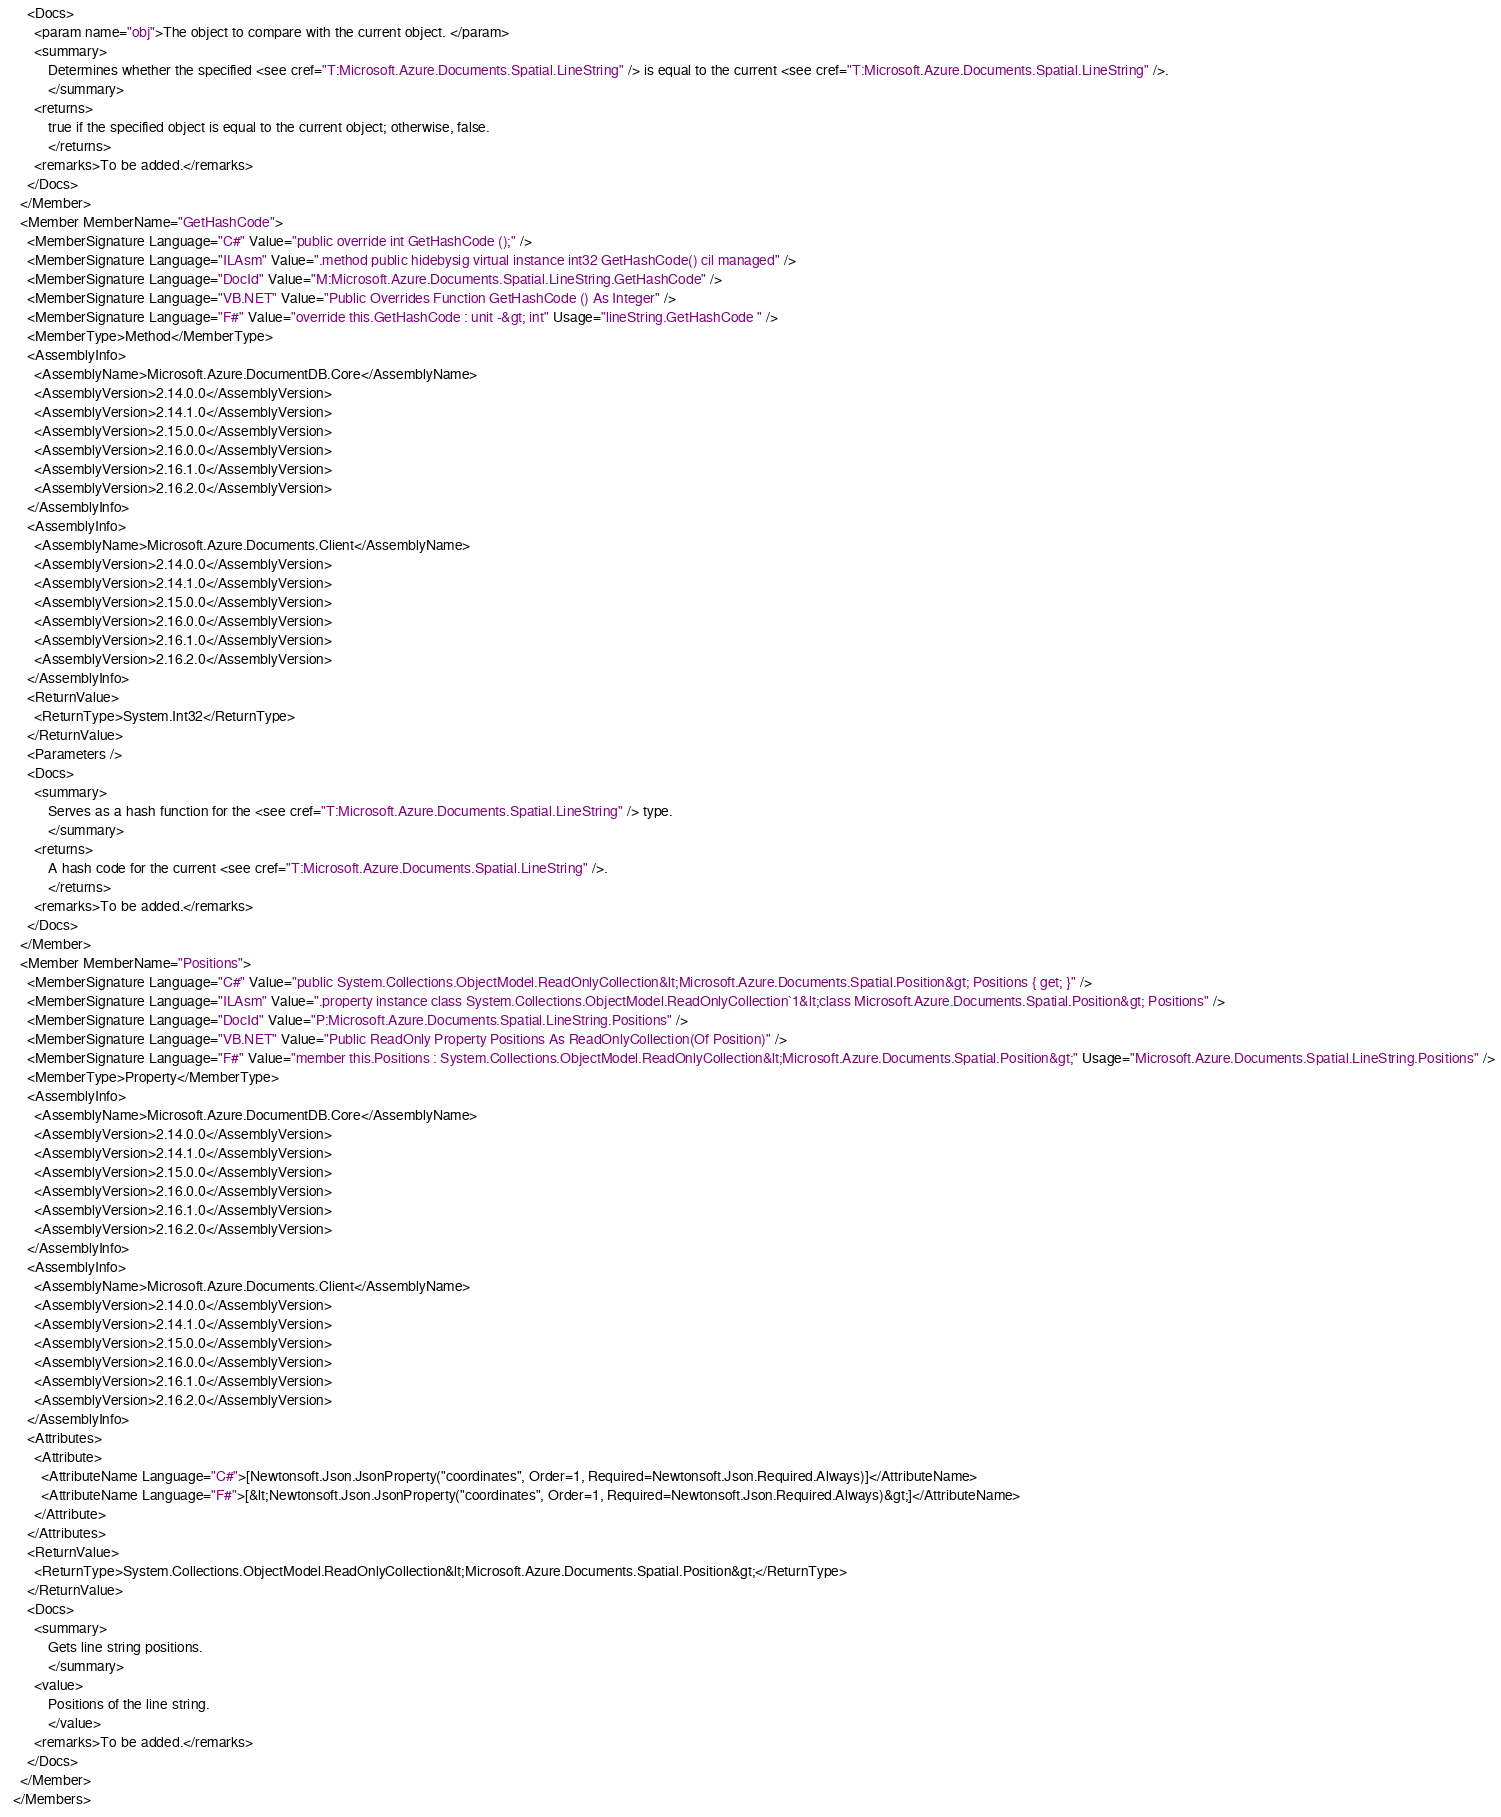Convert code to text. <code><loc_0><loc_0><loc_500><loc_500><_XML_>      <Docs>
        <param name="obj">The object to compare with the current object. </param>
        <summary>
            Determines whether the specified <see cref="T:Microsoft.Azure.Documents.Spatial.LineString" /> is equal to the current <see cref="T:Microsoft.Azure.Documents.Spatial.LineString" />.
            </summary>
        <returns>
            true if the specified object is equal to the current object; otherwise, false.
            </returns>
        <remarks>To be added.</remarks>
      </Docs>
    </Member>
    <Member MemberName="GetHashCode">
      <MemberSignature Language="C#" Value="public override int GetHashCode ();" />
      <MemberSignature Language="ILAsm" Value=".method public hidebysig virtual instance int32 GetHashCode() cil managed" />
      <MemberSignature Language="DocId" Value="M:Microsoft.Azure.Documents.Spatial.LineString.GetHashCode" />
      <MemberSignature Language="VB.NET" Value="Public Overrides Function GetHashCode () As Integer" />
      <MemberSignature Language="F#" Value="override this.GetHashCode : unit -&gt; int" Usage="lineString.GetHashCode " />
      <MemberType>Method</MemberType>
      <AssemblyInfo>
        <AssemblyName>Microsoft.Azure.DocumentDB.Core</AssemblyName>
        <AssemblyVersion>2.14.0.0</AssemblyVersion>
        <AssemblyVersion>2.14.1.0</AssemblyVersion>
        <AssemblyVersion>2.15.0.0</AssemblyVersion>
        <AssemblyVersion>2.16.0.0</AssemblyVersion>
        <AssemblyVersion>2.16.1.0</AssemblyVersion>
        <AssemblyVersion>2.16.2.0</AssemblyVersion>
      </AssemblyInfo>
      <AssemblyInfo>
        <AssemblyName>Microsoft.Azure.Documents.Client</AssemblyName>
        <AssemblyVersion>2.14.0.0</AssemblyVersion>
        <AssemblyVersion>2.14.1.0</AssemblyVersion>
        <AssemblyVersion>2.15.0.0</AssemblyVersion>
        <AssemblyVersion>2.16.0.0</AssemblyVersion>
        <AssemblyVersion>2.16.1.0</AssemblyVersion>
        <AssemblyVersion>2.16.2.0</AssemblyVersion>
      </AssemblyInfo>
      <ReturnValue>
        <ReturnType>System.Int32</ReturnType>
      </ReturnValue>
      <Parameters />
      <Docs>
        <summary>
            Serves as a hash function for the <see cref="T:Microsoft.Azure.Documents.Spatial.LineString" /> type.
            </summary>
        <returns>
            A hash code for the current <see cref="T:Microsoft.Azure.Documents.Spatial.LineString" />.
            </returns>
        <remarks>To be added.</remarks>
      </Docs>
    </Member>
    <Member MemberName="Positions">
      <MemberSignature Language="C#" Value="public System.Collections.ObjectModel.ReadOnlyCollection&lt;Microsoft.Azure.Documents.Spatial.Position&gt; Positions { get; }" />
      <MemberSignature Language="ILAsm" Value=".property instance class System.Collections.ObjectModel.ReadOnlyCollection`1&lt;class Microsoft.Azure.Documents.Spatial.Position&gt; Positions" />
      <MemberSignature Language="DocId" Value="P:Microsoft.Azure.Documents.Spatial.LineString.Positions" />
      <MemberSignature Language="VB.NET" Value="Public ReadOnly Property Positions As ReadOnlyCollection(Of Position)" />
      <MemberSignature Language="F#" Value="member this.Positions : System.Collections.ObjectModel.ReadOnlyCollection&lt;Microsoft.Azure.Documents.Spatial.Position&gt;" Usage="Microsoft.Azure.Documents.Spatial.LineString.Positions" />
      <MemberType>Property</MemberType>
      <AssemblyInfo>
        <AssemblyName>Microsoft.Azure.DocumentDB.Core</AssemblyName>
        <AssemblyVersion>2.14.0.0</AssemblyVersion>
        <AssemblyVersion>2.14.1.0</AssemblyVersion>
        <AssemblyVersion>2.15.0.0</AssemblyVersion>
        <AssemblyVersion>2.16.0.0</AssemblyVersion>
        <AssemblyVersion>2.16.1.0</AssemblyVersion>
        <AssemblyVersion>2.16.2.0</AssemblyVersion>
      </AssemblyInfo>
      <AssemblyInfo>
        <AssemblyName>Microsoft.Azure.Documents.Client</AssemblyName>
        <AssemblyVersion>2.14.0.0</AssemblyVersion>
        <AssemblyVersion>2.14.1.0</AssemblyVersion>
        <AssemblyVersion>2.15.0.0</AssemblyVersion>
        <AssemblyVersion>2.16.0.0</AssemblyVersion>
        <AssemblyVersion>2.16.1.0</AssemblyVersion>
        <AssemblyVersion>2.16.2.0</AssemblyVersion>
      </AssemblyInfo>
      <Attributes>
        <Attribute>
          <AttributeName Language="C#">[Newtonsoft.Json.JsonProperty("coordinates", Order=1, Required=Newtonsoft.Json.Required.Always)]</AttributeName>
          <AttributeName Language="F#">[&lt;Newtonsoft.Json.JsonProperty("coordinates", Order=1, Required=Newtonsoft.Json.Required.Always)&gt;]</AttributeName>
        </Attribute>
      </Attributes>
      <ReturnValue>
        <ReturnType>System.Collections.ObjectModel.ReadOnlyCollection&lt;Microsoft.Azure.Documents.Spatial.Position&gt;</ReturnType>
      </ReturnValue>
      <Docs>
        <summary>
            Gets line string positions.
            </summary>
        <value>
            Positions of the line string.
            </value>
        <remarks>To be added.</remarks>
      </Docs>
    </Member>
  </Members></code> 